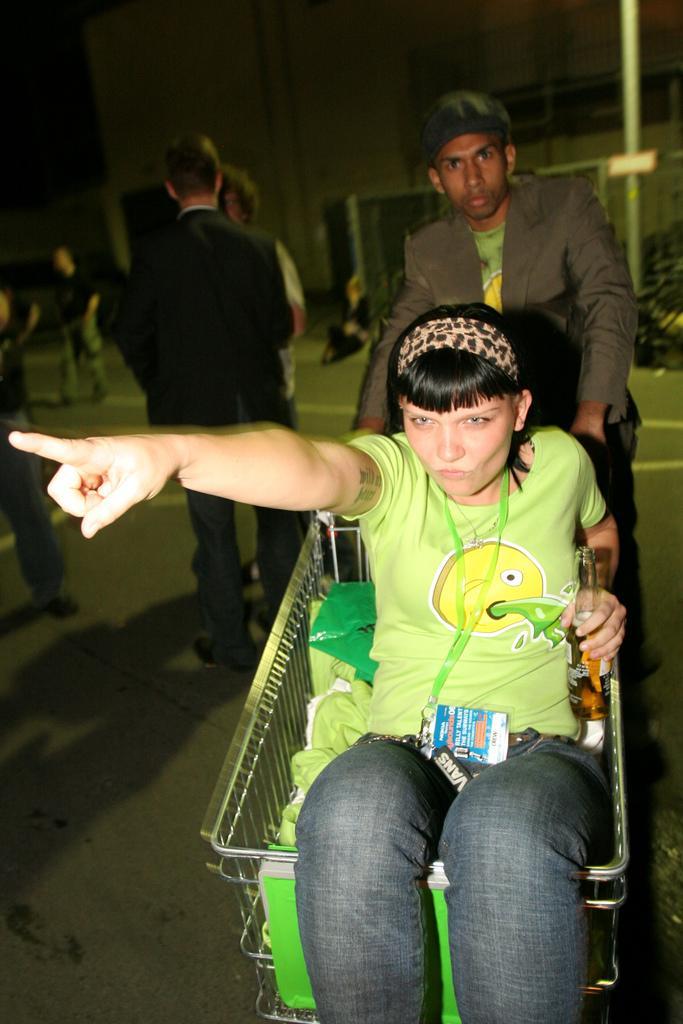How would you summarize this image in a sentence or two? The woman in front of the picture who is wearing the green T-shirt is sitting on the shopping trolley. She is pointing her finger towards something. Behind her, we see a man in grey blazer is standing. Behind him, we see many people are standing on the road. In the background, we see a wall and a pole. This picture is clicked in the dark. 